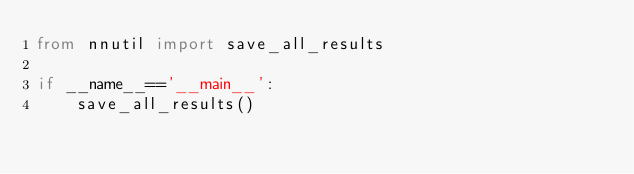Convert code to text. <code><loc_0><loc_0><loc_500><loc_500><_Python_>from nnutil import save_all_results

if __name__=='__main__':
    save_all_results()</code> 